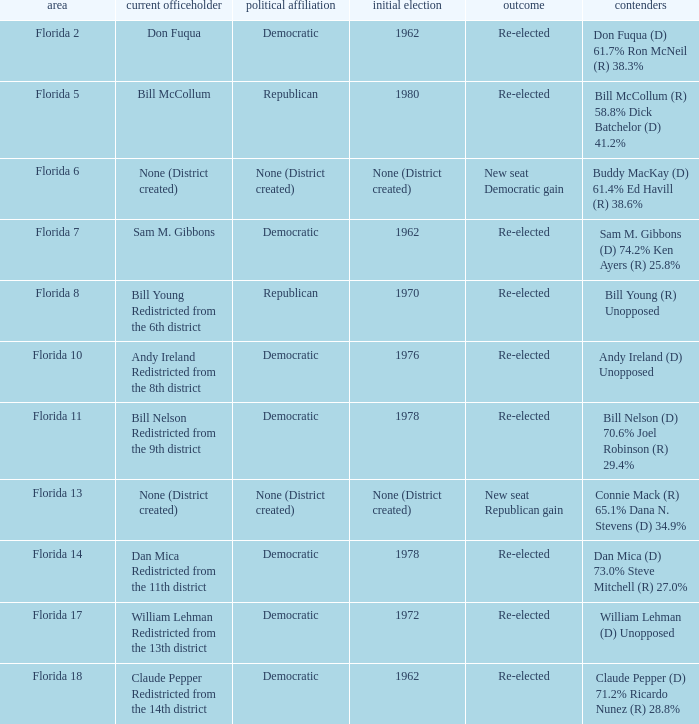 how many candidates with result being new seat democratic gain 1.0. 